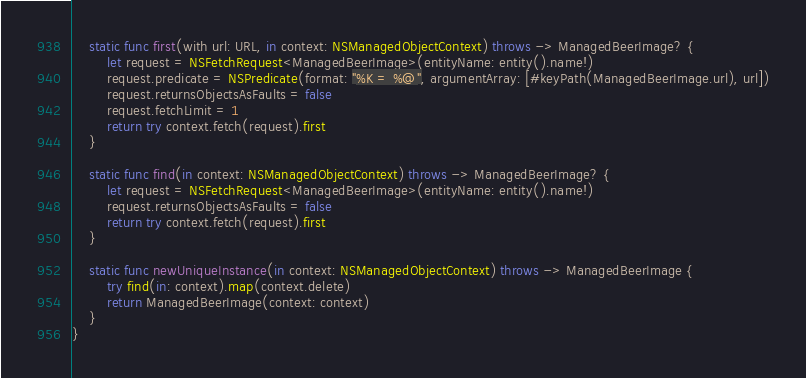Convert code to text. <code><loc_0><loc_0><loc_500><loc_500><_Swift_>    static func first(with url: URL, in context: NSManagedObjectContext) throws -> ManagedBeerImage? {
        let request = NSFetchRequest<ManagedBeerImage>(entityName: entity().name!)
        request.predicate = NSPredicate(format: "%K = %@", argumentArray: [#keyPath(ManagedBeerImage.url), url])
        request.returnsObjectsAsFaults = false
        request.fetchLimit = 1
        return try context.fetch(request).first
    }
    
    static func find(in context: NSManagedObjectContext) throws -> ManagedBeerImage? {
        let request = NSFetchRequest<ManagedBeerImage>(entityName: entity().name!)
        request.returnsObjectsAsFaults = false
        return try context.fetch(request).first
    }
    
    static func newUniqueInstance(in context: NSManagedObjectContext) throws -> ManagedBeerImage {
        try find(in: context).map(context.delete)
        return ManagedBeerImage(context: context)
    }
}
</code> 